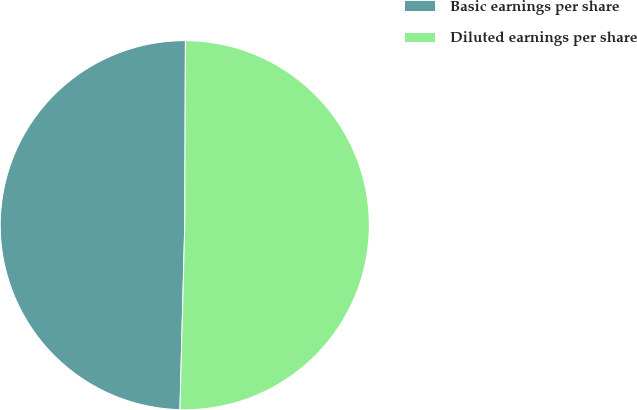Convert chart to OTSL. <chart><loc_0><loc_0><loc_500><loc_500><pie_chart><fcel>Basic earnings per share<fcel>Diluted earnings per share<nl><fcel>49.64%<fcel>50.36%<nl></chart> 